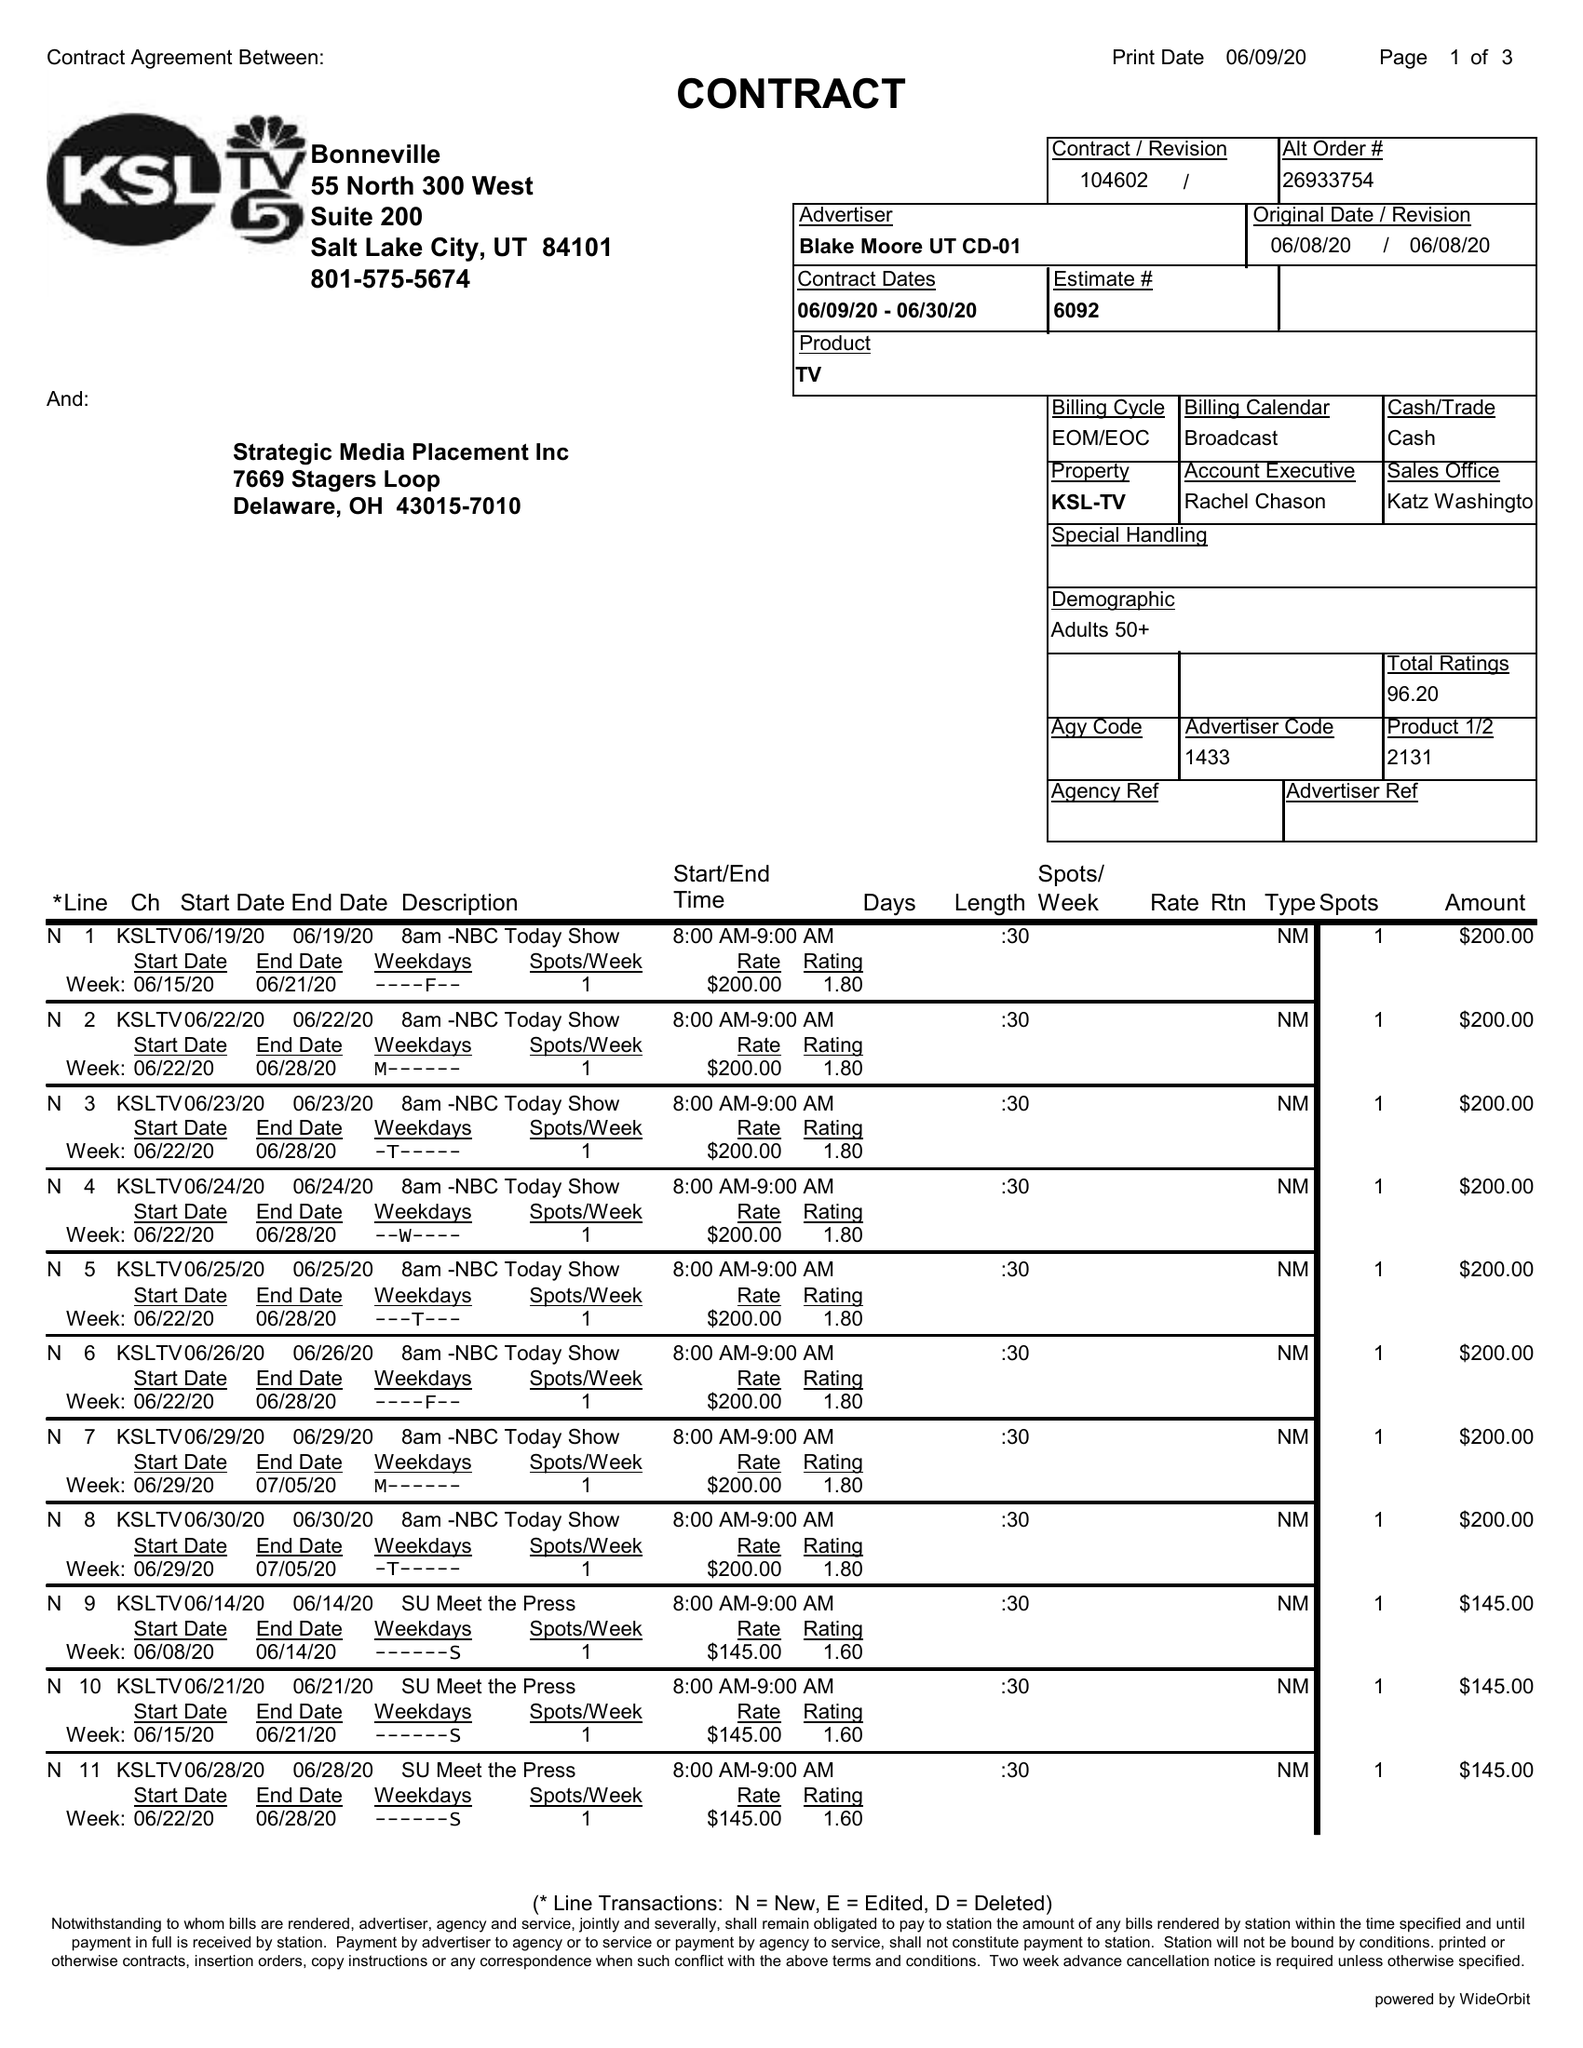What is the value for the contract_num?
Answer the question using a single word or phrase. 104602 